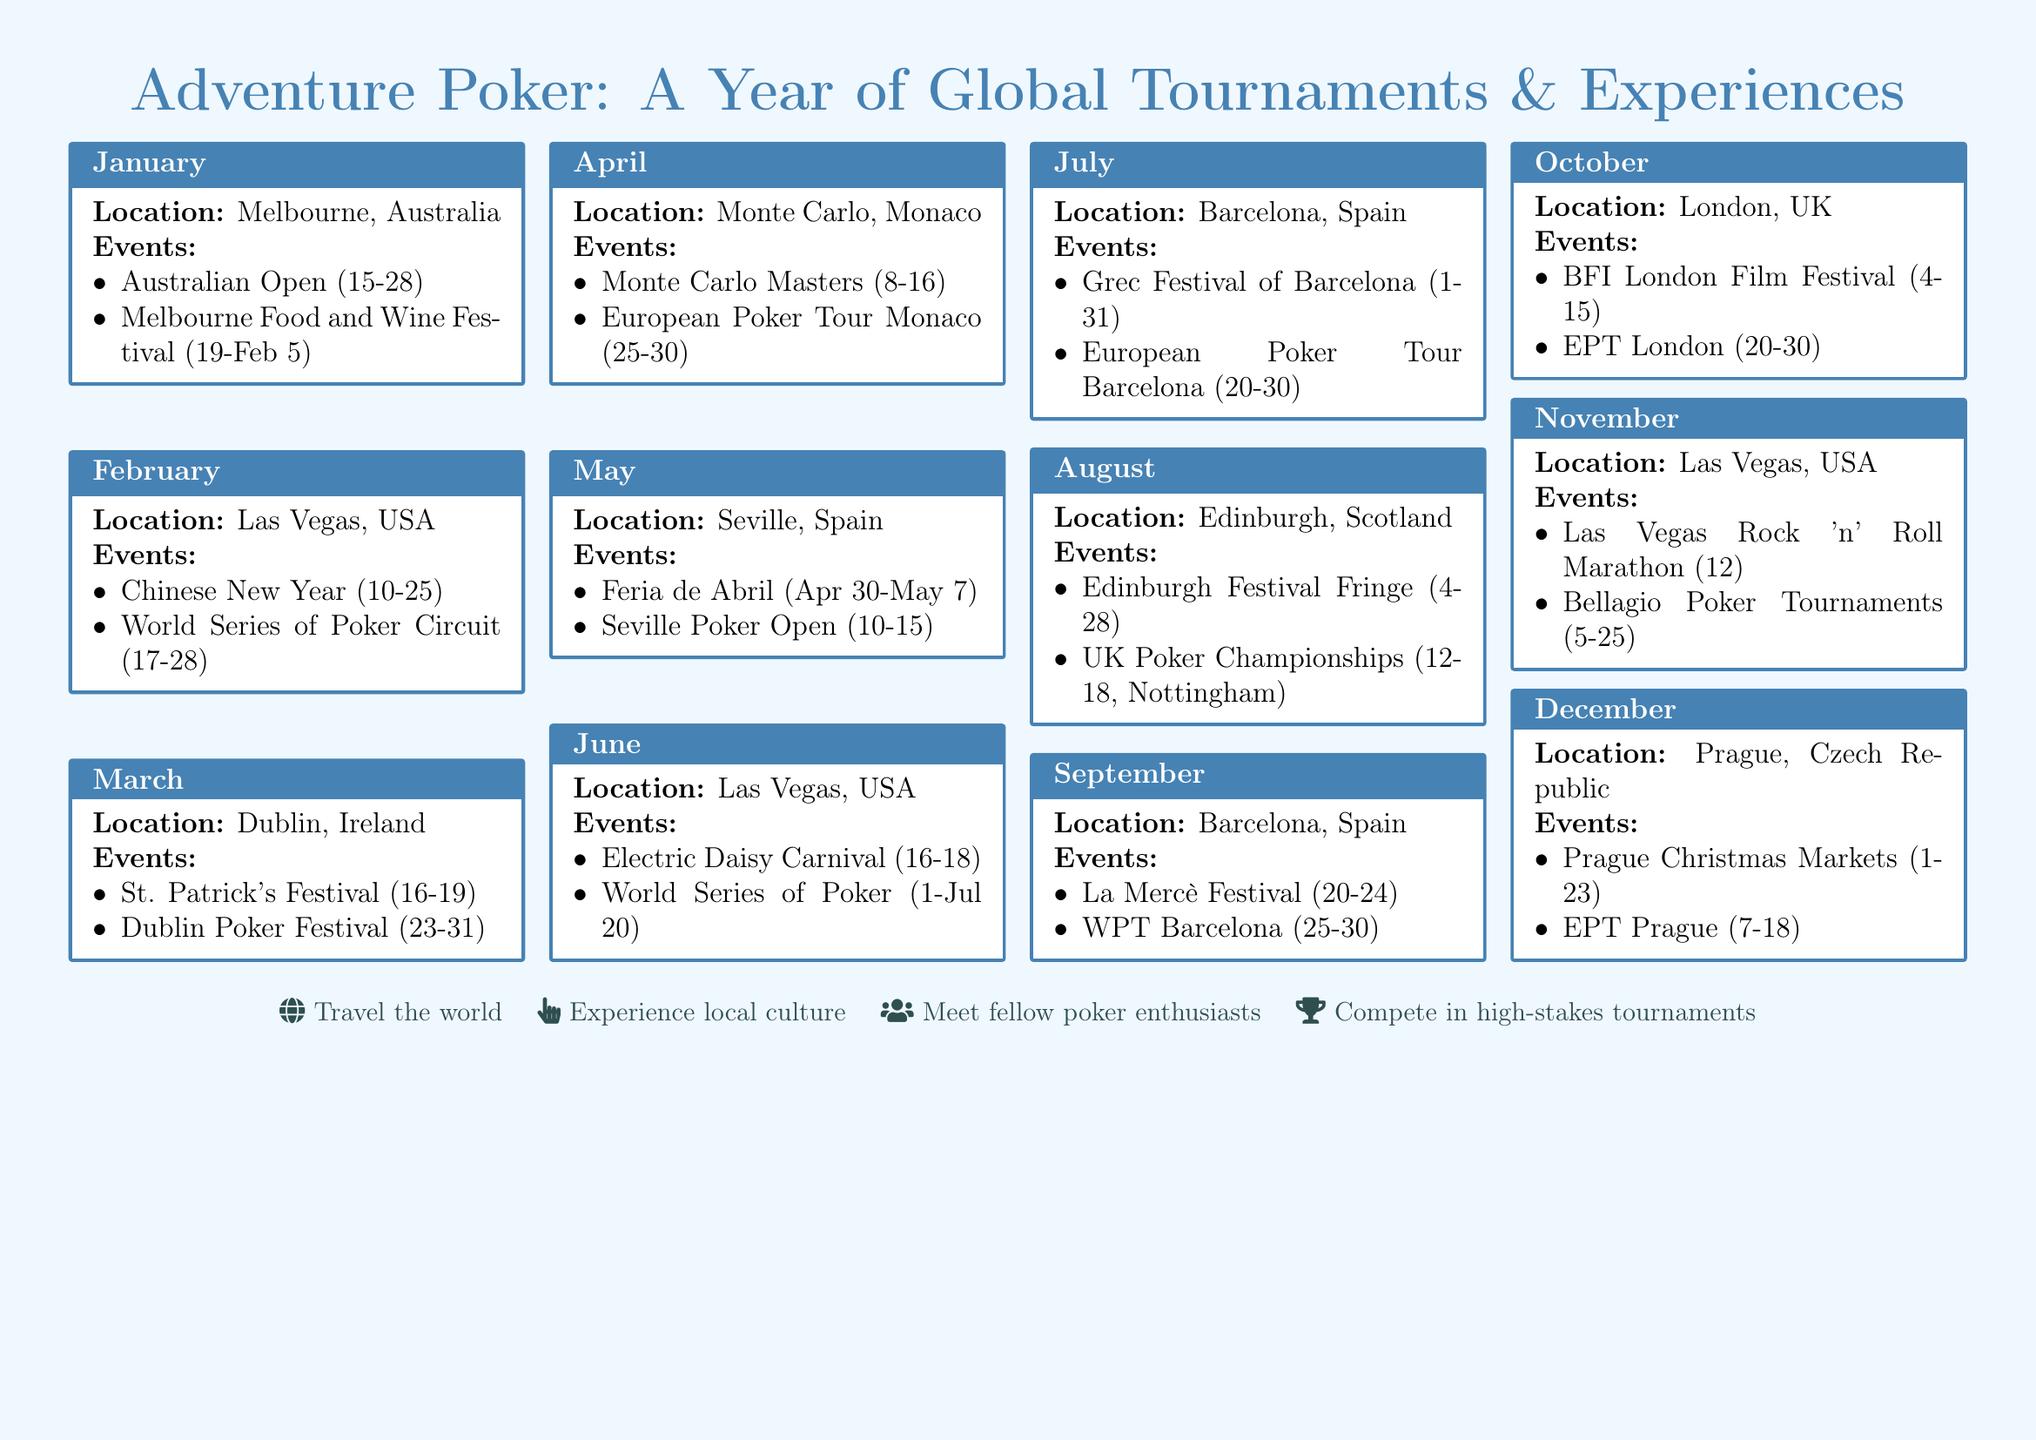What is the location for the February events? The location listed for February events is Las Vegas, USA.
Answer: Las Vegas, USA What festivals occur in January in Melbourne? The festivals in January are the Australian Open and the Melbourne Food and Wine Festival.
Answer: Australian Open, Melbourne Food and Wine Festival How many poker events are listed for December? In December, there are two events: the Prague Christmas Markets and the EPT Prague.
Answer: 2 What is the date range for the World Series of Poker in June? The date range for the World Series of Poker in June is from July 1 to July 20.
Answer: July 1 - July 20 Which city hosts the Edinburgh Festival Fringe? The city hosting the Edinburgh Festival Fringe is Edinburgh, Scotland.
Answer: Edinburgh, Scotland Which event overlaps with the Feria de Abril in Seville? The Seville Poker Open overlaps with the Feria de Abril.
Answer: Seville Poker Open What is the last date of the WPT Barcelona festival? The last date of the WPT Barcelona festival is September 30.
Answer: September 30 Which month has the most poker events listed? The month with the most poker events is June, with two events.
Answer: June What is the title of the calendar document? The title of the calendar document is "Adventure Poker: A Year of Global Tournaments & Experiences."
Answer: Adventure Poker: A Year of Global Tournaments & Experiences 